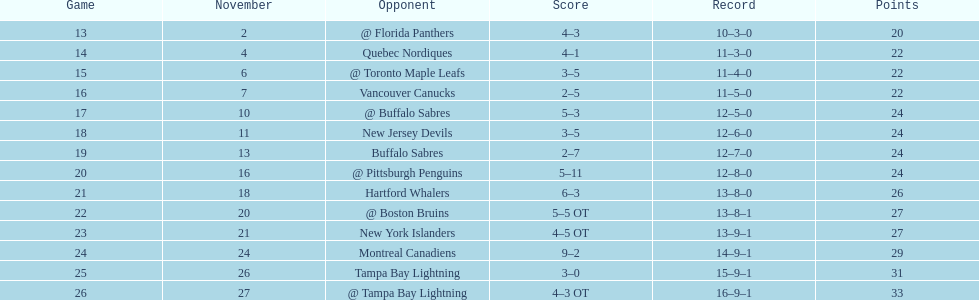Did the tampa bay lightning have the least amount of wins? Yes. 